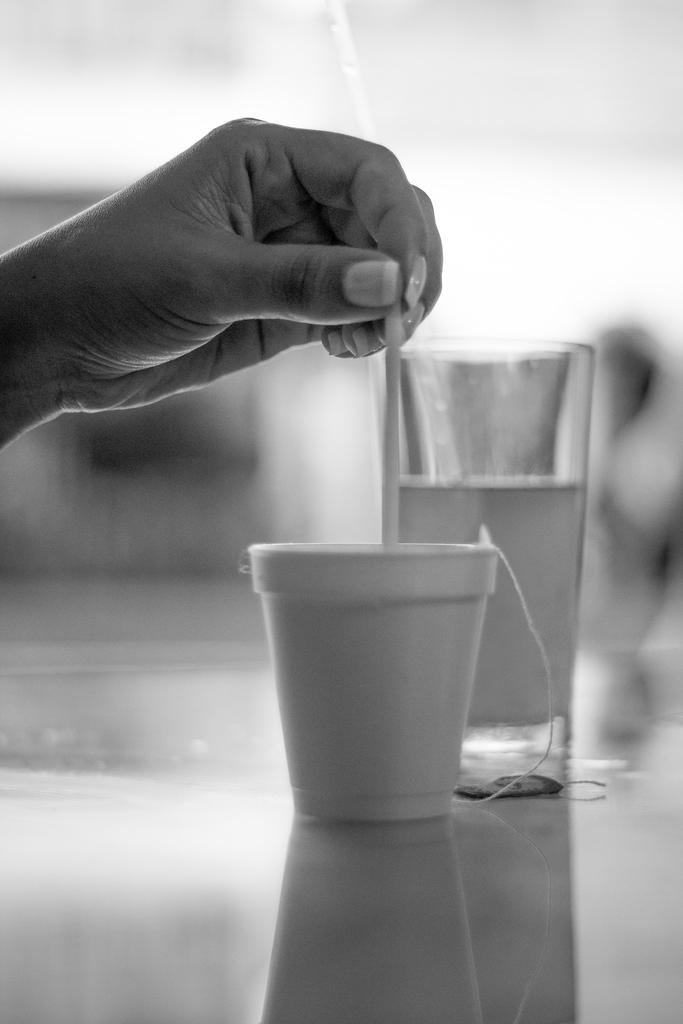What is the color scheme of the image? The image is black and white. What can be seen being held by a hand in the image? There is a hand holding a stick in the image. What objects are in the middle of the image? There is a cup and a glass in the middle of the image. How would you describe the background of the image? The background of the image is blurred. What type of cushion is being used toasted in the image? There is no cushion present in the image, and no toasting is taking place. 